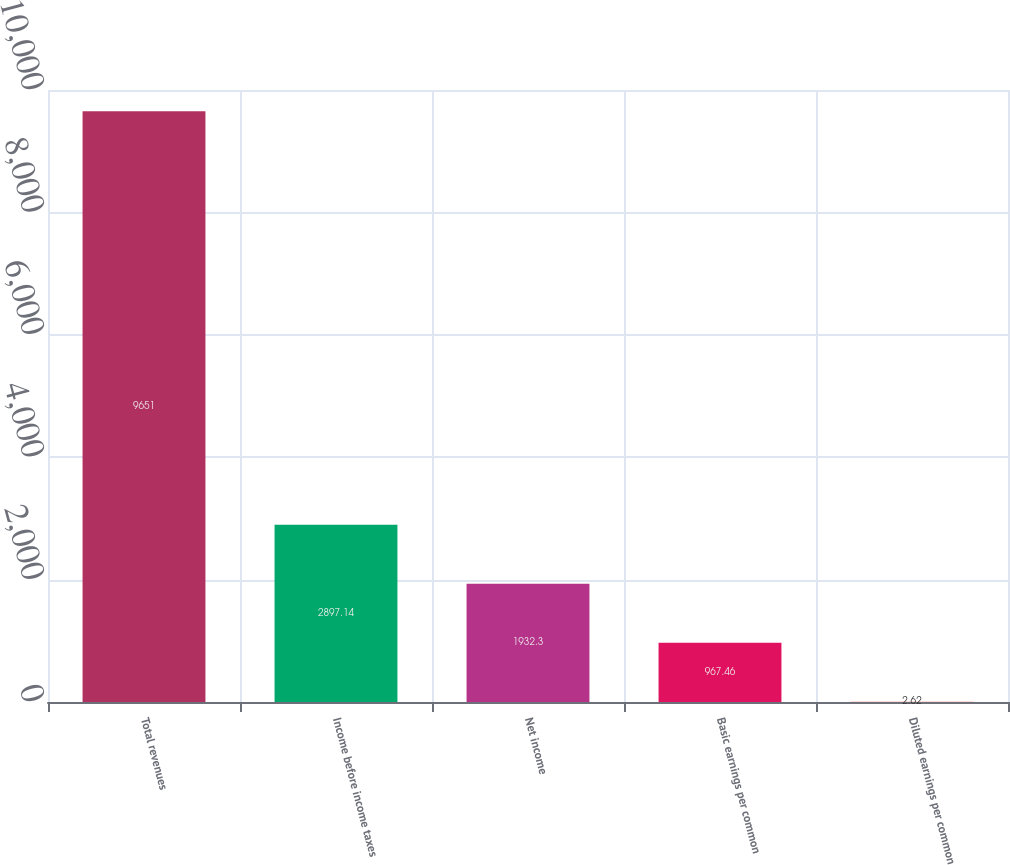Convert chart. <chart><loc_0><loc_0><loc_500><loc_500><bar_chart><fcel>Total revenues<fcel>Income before income taxes<fcel>Net income<fcel>Basic earnings per common<fcel>Diluted earnings per common<nl><fcel>9651<fcel>2897.14<fcel>1932.3<fcel>967.46<fcel>2.62<nl></chart> 